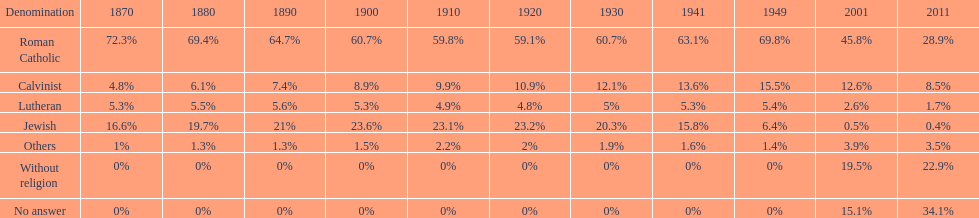Which religious group has the largest margin? Roman Catholic. 